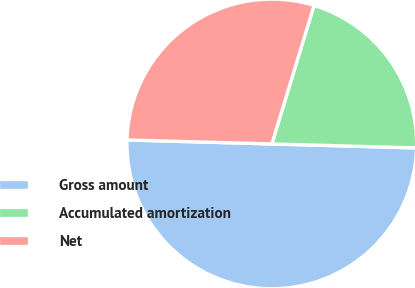Convert chart. <chart><loc_0><loc_0><loc_500><loc_500><pie_chart><fcel>Gross amount<fcel>Accumulated amortization<fcel>Net<nl><fcel>50.0%<fcel>20.73%<fcel>29.27%<nl></chart> 